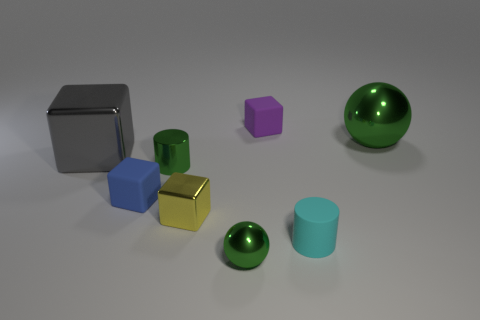Are there fewer big balls than tiny cyan shiny things?
Ensure brevity in your answer.  No. There is a small blue thing that is made of the same material as the small cyan cylinder; what shape is it?
Ensure brevity in your answer.  Cube. There is a tiny cyan rubber thing; are there any green metallic objects behind it?
Offer a very short reply. Yes. Is the number of gray blocks that are behind the big gray cube less than the number of objects?
Your response must be concise. Yes. What is the tiny cyan cylinder made of?
Offer a terse response. Rubber. The tiny shiny cube has what color?
Your answer should be compact. Yellow. There is a shiny thing that is both behind the green metal cylinder and on the right side of the yellow block; what is its color?
Keep it short and to the point. Green. Do the tiny blue object and the tiny green object that is behind the blue matte block have the same material?
Give a very brief answer. No. There is a gray metal object on the left side of the large object that is to the right of the small blue matte block; how big is it?
Offer a terse response. Large. Are there any other things that are the same color as the metallic cylinder?
Your answer should be very brief. Yes. 